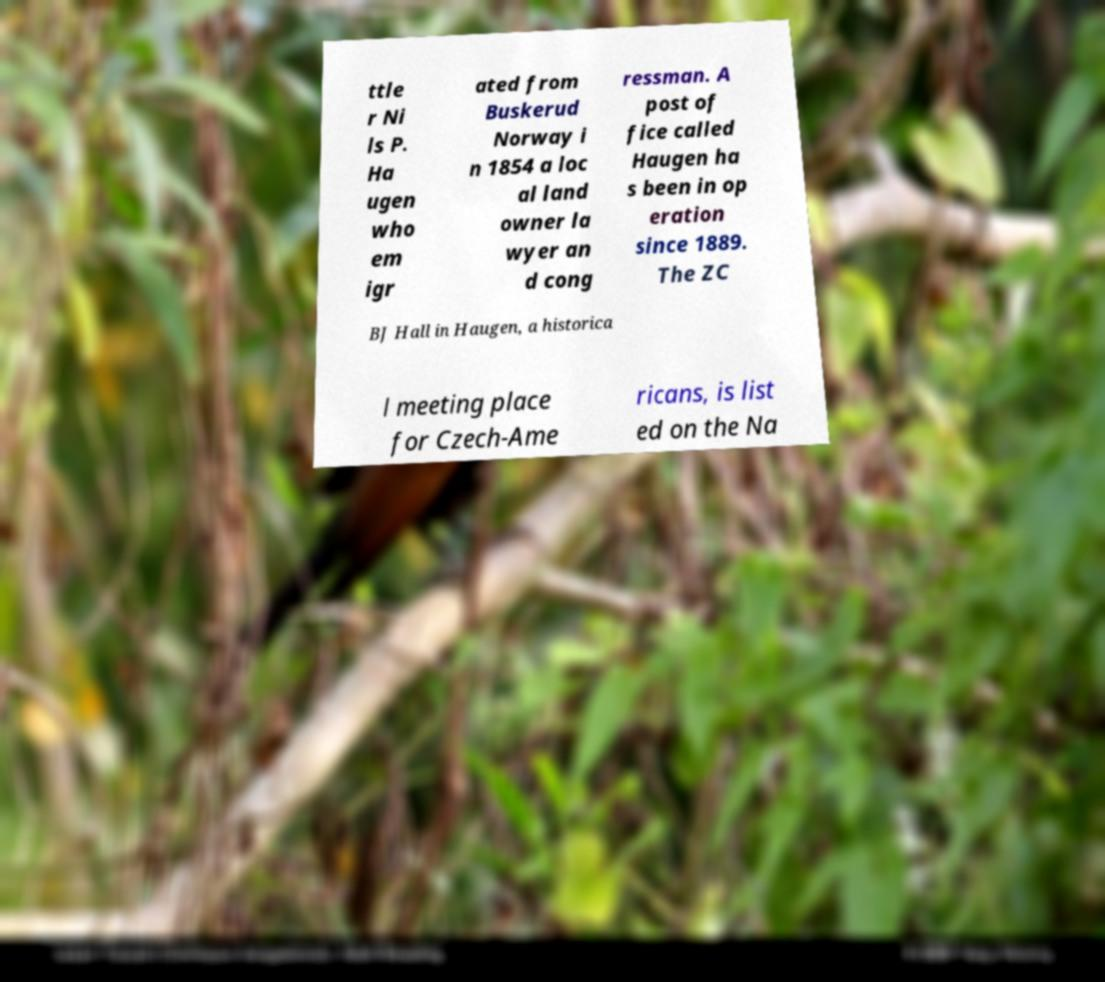Could you assist in decoding the text presented in this image and type it out clearly? ttle r Ni ls P. Ha ugen who em igr ated from Buskerud Norway i n 1854 a loc al land owner la wyer an d cong ressman. A post of fice called Haugen ha s been in op eration since 1889. The ZC BJ Hall in Haugen, a historica l meeting place for Czech-Ame ricans, is list ed on the Na 